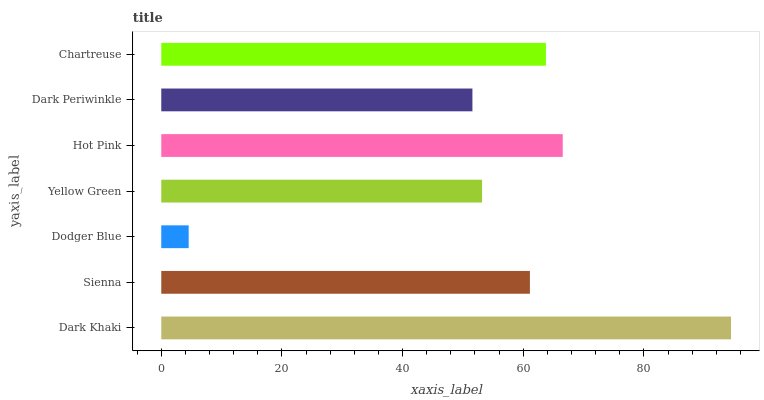Is Dodger Blue the minimum?
Answer yes or no. Yes. Is Dark Khaki the maximum?
Answer yes or no. Yes. Is Sienna the minimum?
Answer yes or no. No. Is Sienna the maximum?
Answer yes or no. No. Is Dark Khaki greater than Sienna?
Answer yes or no. Yes. Is Sienna less than Dark Khaki?
Answer yes or no. Yes. Is Sienna greater than Dark Khaki?
Answer yes or no. No. Is Dark Khaki less than Sienna?
Answer yes or no. No. Is Sienna the high median?
Answer yes or no. Yes. Is Sienna the low median?
Answer yes or no. Yes. Is Yellow Green the high median?
Answer yes or no. No. Is Chartreuse the low median?
Answer yes or no. No. 